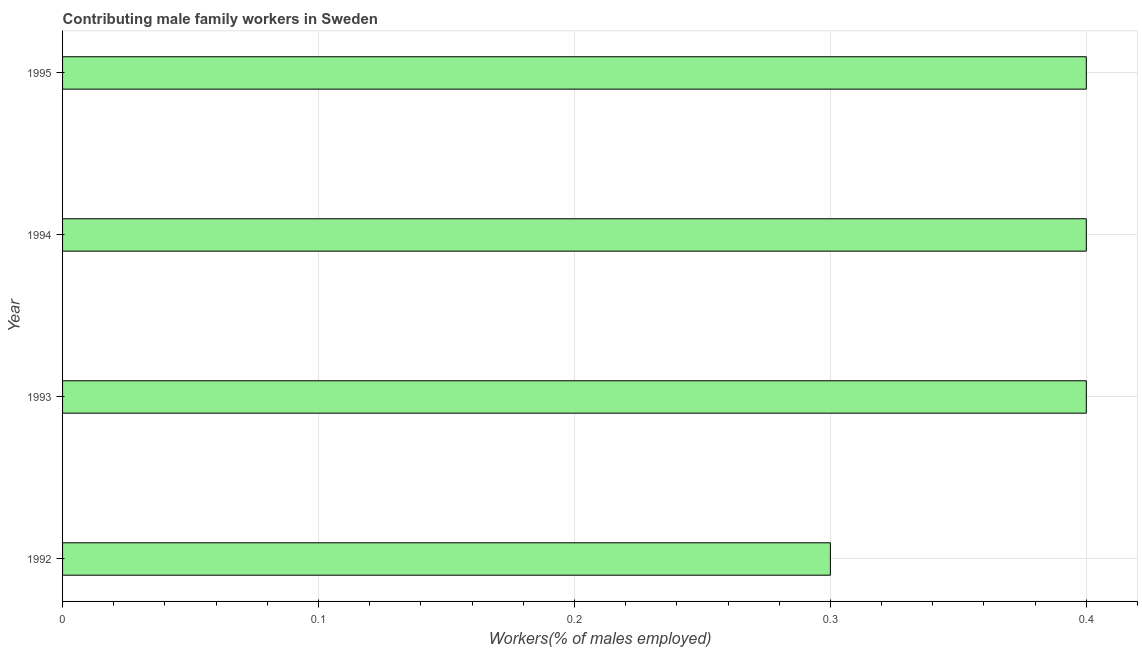Does the graph contain any zero values?
Your answer should be very brief. No. What is the title of the graph?
Offer a terse response. Contributing male family workers in Sweden. What is the label or title of the X-axis?
Your answer should be very brief. Workers(% of males employed). What is the contributing male family workers in 1993?
Ensure brevity in your answer.  0.4. Across all years, what is the maximum contributing male family workers?
Keep it short and to the point. 0.4. Across all years, what is the minimum contributing male family workers?
Your response must be concise. 0.3. In which year was the contributing male family workers maximum?
Ensure brevity in your answer.  1993. In which year was the contributing male family workers minimum?
Keep it short and to the point. 1992. What is the sum of the contributing male family workers?
Provide a succinct answer. 1.5. What is the difference between the contributing male family workers in 1993 and 1995?
Offer a terse response. 0. What is the median contributing male family workers?
Make the answer very short. 0.4. Is the contributing male family workers in 1992 less than that in 1994?
Your answer should be compact. Yes. What is the difference between the highest and the second highest contributing male family workers?
Your answer should be compact. 0. What is the difference between the highest and the lowest contributing male family workers?
Your response must be concise. 0.1. How many years are there in the graph?
Offer a very short reply. 4. What is the Workers(% of males employed) of 1992?
Provide a short and direct response. 0.3. What is the Workers(% of males employed) of 1993?
Your answer should be compact. 0.4. What is the Workers(% of males employed) of 1994?
Your response must be concise. 0.4. What is the Workers(% of males employed) of 1995?
Your answer should be compact. 0.4. What is the difference between the Workers(% of males employed) in 1992 and 1994?
Your response must be concise. -0.1. What is the difference between the Workers(% of males employed) in 1992 and 1995?
Your answer should be very brief. -0.1. What is the ratio of the Workers(% of males employed) in 1993 to that in 1995?
Your answer should be compact. 1. What is the ratio of the Workers(% of males employed) in 1994 to that in 1995?
Offer a very short reply. 1. 